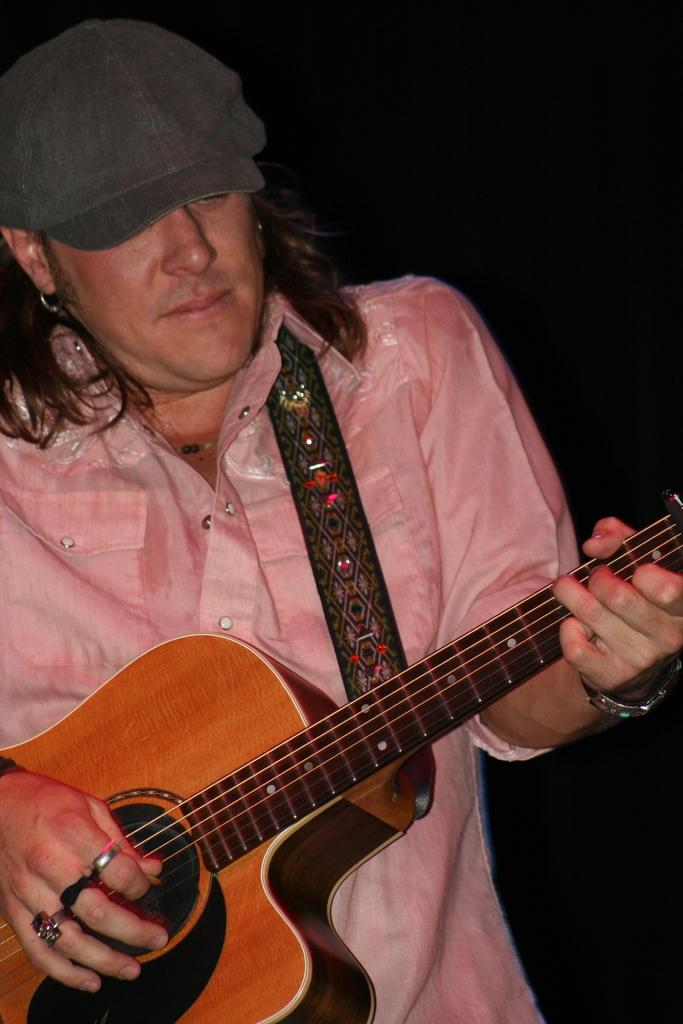What is the man in the picture doing? The man is playing a guitar. What is the man wearing on his upper body? The man is wearing a pink shirt. What type of headwear is the man wearing? The man is wearing a black cap on his head. What accessory is the man wearing on his ear? The man has an earring on his ear. What timepiece is the man wearing on his wrist? The man is wearing a watch on his wrist. What type of pancake is the man flipping in the image? There is no pancake present in the image; the man is playing a guitar. What type of cabbage is the man holding in the image? There is no cabbage present in the image; the man is playing a guitar and wearing various accessories. 